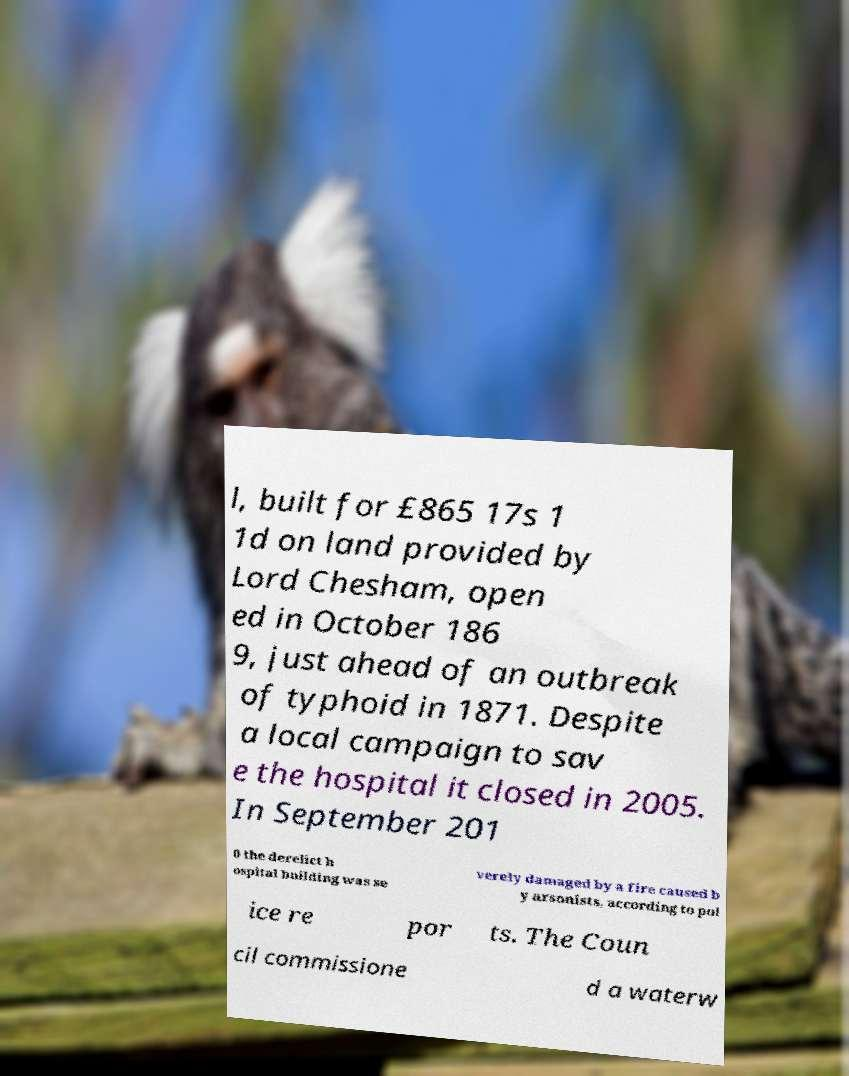Could you assist in decoding the text presented in this image and type it out clearly? l, built for £865 17s 1 1d on land provided by Lord Chesham, open ed in October 186 9, just ahead of an outbreak of typhoid in 1871. Despite a local campaign to sav e the hospital it closed in 2005. In September 201 0 the derelict h ospital building was se verely damaged by a fire caused b y arsonists, according to pol ice re por ts. The Coun cil commissione d a waterw 